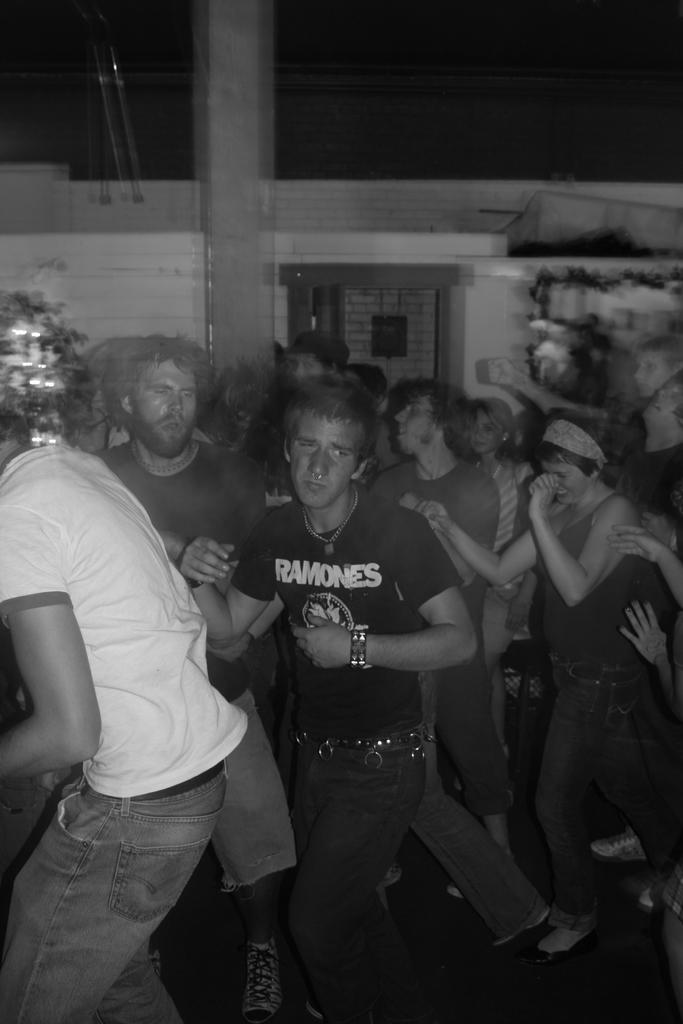How many people are in the image? There are two men in the image. What are the men doing in the image? The men are standing and dancing in the image. What is the color scheme of the image? The image is in black and white. Where are the men located in the image? The men are on a floor in the image. What can be seen in the background of the image? There is a wall in the background of the image. What type of furniture can be seen in the image? There is no furniture present in the image. How many beds are visible in the image? There are no beds visible in the image. 